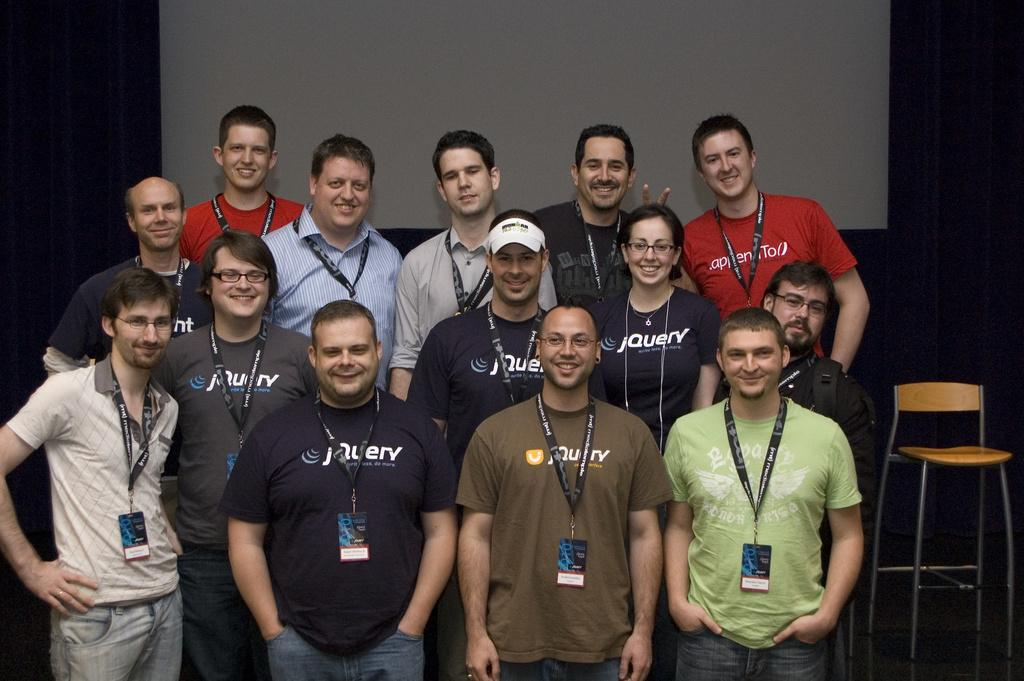How many people are in the image? There is a group of men and a woman in the image, making a total of at least four people. What are the people in the image doing? The group of people is posing for a camera. Can you describe the gender distribution in the image? There are more men than women in the image. What type of fruit is being weighed on the scale in the image? There is no scale or fruit present in the image. 